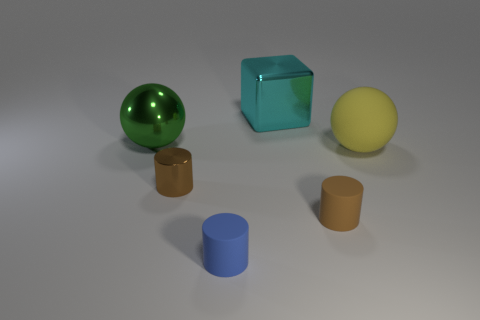The big object behind the big ball behind the big sphere that is on the right side of the metallic cylinder is what shape? The big object positioned behind the big, green, reflective ball, which in turn is located behind the the largest sphere on the right side of the image, adjacent to the metallic cylinder, is a cube with a turquoise hue and a semi-transparent appearance. 